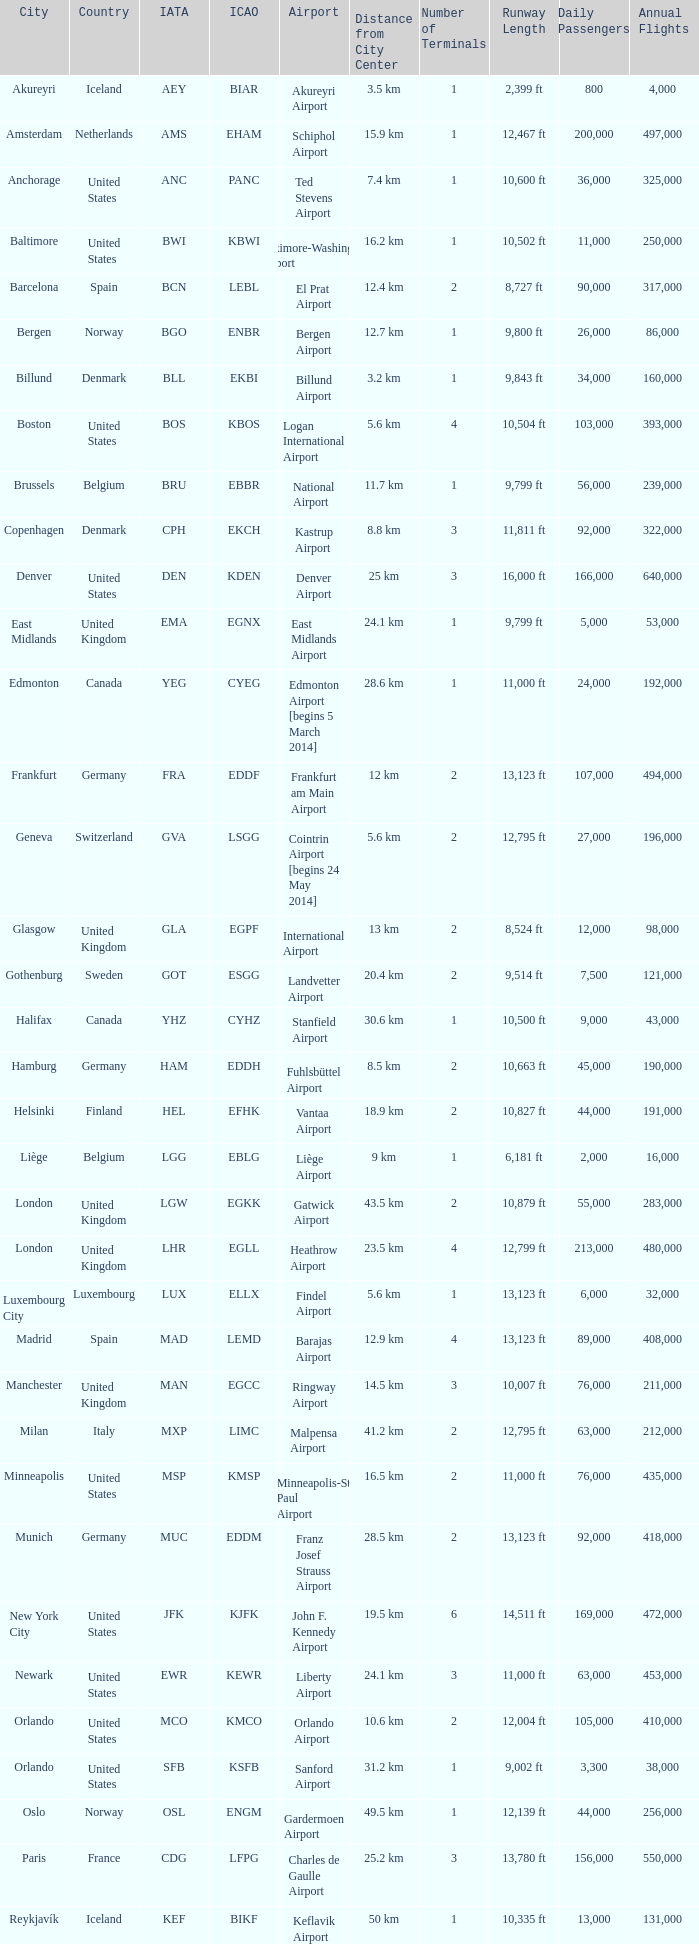Could you parse the entire table as a dict? {'header': ['City', 'Country', 'IATA', 'ICAO', 'Airport', 'Distance from City Center', 'Number of Terminals', 'Runway Length', 'Daily Passengers', 'Annual Flights '], 'rows': [['Akureyri', 'Iceland', 'AEY', 'BIAR', 'Akureyri Airport', '3.5 km', '1', '2,399 ft', '800', '4,000 '], ['Amsterdam', 'Netherlands', 'AMS', 'EHAM', 'Schiphol Airport', '15.9 km', '1', '12,467 ft', '200,000', '497,000 '], ['Anchorage', 'United States', 'ANC', 'PANC', 'Ted Stevens Airport', '7.4 km', '1', '10,600 ft', '36,000', '325,000 '], ['Baltimore', 'United States', 'BWI', 'KBWI', 'Baltimore-Washington Airport', '16.2 km', '1', '10,502 ft', '11,000', '250,000 '], ['Barcelona', 'Spain', 'BCN', 'LEBL', 'El Prat Airport', '12.4 km', '2', '8,727 ft', '90,000', '317,000 '], ['Bergen', 'Norway', 'BGO', 'ENBR', 'Bergen Airport', '12.7 km', '1', '9,800 ft', '26,000', '86,000 '], ['Billund', 'Denmark', 'BLL', 'EKBI', 'Billund Airport', '3.2 km', '1', '9,843 ft', '34,000', '160,000 '], ['Boston', 'United States', 'BOS', 'KBOS', 'Logan International Airport', '5.6 km', '4', '10,504 ft', '103,000', '393,000 '], ['Brussels', 'Belgium', 'BRU', 'EBBR', 'National Airport', '11.7 km', '1', '9,799 ft', '56,000', '239,000 '], ['Copenhagen', 'Denmark', 'CPH', 'EKCH', 'Kastrup Airport', '8.8 km', '3', '11,811 ft', '92,000', '322,000 '], ['Denver', 'United States', 'DEN', 'KDEN', 'Denver Airport', '25 km', '3', '16,000 ft', '166,000', '640,000 '], ['East Midlands', 'United Kingdom', 'EMA', 'EGNX', 'East Midlands Airport', '24.1 km', '1', '9,799 ft', '5,000', '53,000 '], ['Edmonton', 'Canada', 'YEG', 'CYEG', 'Edmonton Airport [begins 5 March 2014]', '28.6 km', '1', '11,000 ft', '24,000', '192,000 '], ['Frankfurt', 'Germany', 'FRA', 'EDDF', 'Frankfurt am Main Airport', '12 km', '2', '13,123 ft', '107,000', '494,000 '], ['Geneva', 'Switzerland', 'GVA', 'LSGG', 'Cointrin Airport [begins 24 May 2014]', '5.6 km', '2', '12,795 ft', '27,000', '196,000 '], ['Glasgow', 'United Kingdom', 'GLA', 'EGPF', 'International Airport', '13 km', '2', '8,524 ft', '12,000', '98,000 '], ['Gothenburg', 'Sweden', 'GOT', 'ESGG', 'Landvetter Airport', '20.4 km', '2', '9,514 ft', '7,500', '121,000 '], ['Halifax', 'Canada', 'YHZ', 'CYHZ', 'Stanfield Airport', '30.6 km', '1', '10,500 ft', '9,000', '43,000 '], ['Hamburg', 'Germany', 'HAM', 'EDDH', 'Fuhlsbüttel Airport', '8.5 km', '2', '10,663 ft', '45,000', '190,000 '], ['Helsinki', 'Finland', 'HEL', 'EFHK', 'Vantaa Airport', '18.9 km', '2', '10,827 ft', '44,000', '191,000 '], ['Liège', 'Belgium', 'LGG', 'EBLG', 'Liège Airport', '9 km', '1', '6,181 ft', '2,000', '16,000 '], ['London', 'United Kingdom', 'LGW', 'EGKK', 'Gatwick Airport', '43.5 km', '2', '10,879 ft', '55,000', '283,000 '], ['London', 'United Kingdom', 'LHR', 'EGLL', 'Heathrow Airport', '23.5 km', '4', '12,799 ft', '213,000', '480,000 '], ['Luxembourg City', 'Luxembourg', 'LUX', 'ELLX', 'Findel Airport', '5.6 km', '1', '13,123 ft', '6,000', '32,000 '], ['Madrid', 'Spain', 'MAD', 'LEMD', 'Barajas Airport', '12.9 km', '4', '13,123 ft', '89,000', '408,000 '], ['Manchester', 'United Kingdom', 'MAN', 'EGCC', 'Ringway Airport', '14.5 km', '3', '10,007 ft', '76,000', '211,000 '], ['Milan', 'Italy', 'MXP', 'LIMC', 'Malpensa Airport', '41.2 km', '2', '12,795 ft', '63,000', '212,000 '], ['Minneapolis', 'United States', 'MSP', 'KMSP', 'Minneapolis-St Paul Airport', '16.5 km', '2', '11,000 ft', '76,000', '435,000 '], ['Munich', 'Germany', 'MUC', 'EDDM', 'Franz Josef Strauss Airport', '28.5 km', '2', '13,123 ft', '92,000', '418,000 '], ['New York City', 'United States', 'JFK', 'KJFK', 'John F. Kennedy Airport', '19.5 km', '6', '14,511 ft', '169,000', '472,000 '], ['Newark', 'United States', 'EWR', 'KEWR', 'Liberty Airport', '24.1 km', '3', '11,000 ft', '63,000', '453,000 '], ['Orlando', 'United States', 'MCO', 'KMCO', 'Orlando Airport', '10.6 km', '2', '12,004 ft', '105,000', '410,000 '], ['Orlando', 'United States', 'SFB', 'KSFB', 'Sanford Airport', '31.2 km', '1', '9,002 ft', '3,300', '38,000 '], ['Oslo', 'Norway', 'OSL', 'ENGM', 'Gardermoen Airport', '49.5 km', '1', '12,139 ft', '44,000', '256,000 '], ['Paris', 'France', 'CDG', 'LFPG', 'Charles de Gaulle Airport', '25.2 km', '3', '13,780 ft', '156,000', '550,000 '], ['Reykjavík', 'Iceland', 'KEF', 'BIKF', 'Keflavik Airport', '50 km', '1', '10,335 ft', '13,000', '131,000 '], ['Saint Petersburg', 'Russia', 'LED', 'ULLI', 'Pulkovo Airport', '17 km', '2', '11,483 ft', '19,000', '115,000 '], ['San Francisco', 'United States', 'SFO', 'KSFO', 'San Francisco Airport', '21.7 km', '4', '10,602 ft', '59,000', '380,000 '], ['Seattle', 'United States', 'SEA', 'KSEA', 'Seattle–Tacoma Airport', '22.5 km', '1', '11,901 ft', '50,000', '416,000 '], ['Stavanger', 'Norway', 'SVG', 'ENZV', 'Sola Airport', '11.9 km', '1', '9,022 ft', '5,000', '66,000 '], ['Stockholm', 'Sweden', 'ARN', 'ESSA', 'Arlanda Airport', '37.5 km', '4', '10,102 ft', '74,000', '276,000 '], ['Toronto', 'Canada', 'YYZ', 'CYYZ', 'Pearson Airport', '22.6 km', '2', '11,120 ft', '110,000', '491,000 '], ['Trondheim', 'Norway', 'TRD', 'ENVA', 'Trondheim Airport', '32.4 km', '1', '9,022 ft', '8,000', '92,000 '], ['Vancouver', 'Canada', 'YVR', 'CYVR', 'Vancouver Airport [begins 13 May 2014]', '11.5 km', '3', '10,500 ft', '55,000', '333,000 '], ['Washington, D.C.', 'United States', 'IAD', 'KIAD', 'Dulles Airport', '42.2 km', '1', '11,500 ft', '29,000', '200,000 '], ['Zurich', 'Switzerland', 'ZRH', 'LSZH', 'Kloten Airport', '10.6 km', '3', '12,139 ft', '68,000', '305,000']]} What is the IcAO of Frankfurt? EDDF. 